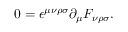Convert formula to latex. <formula><loc_0><loc_0><loc_500><loc_500>0 = \epsilon ^ { \mu \nu \rho \sigma } \partial _ { \mu } F _ { \nu \rho \sigma } .</formula> 